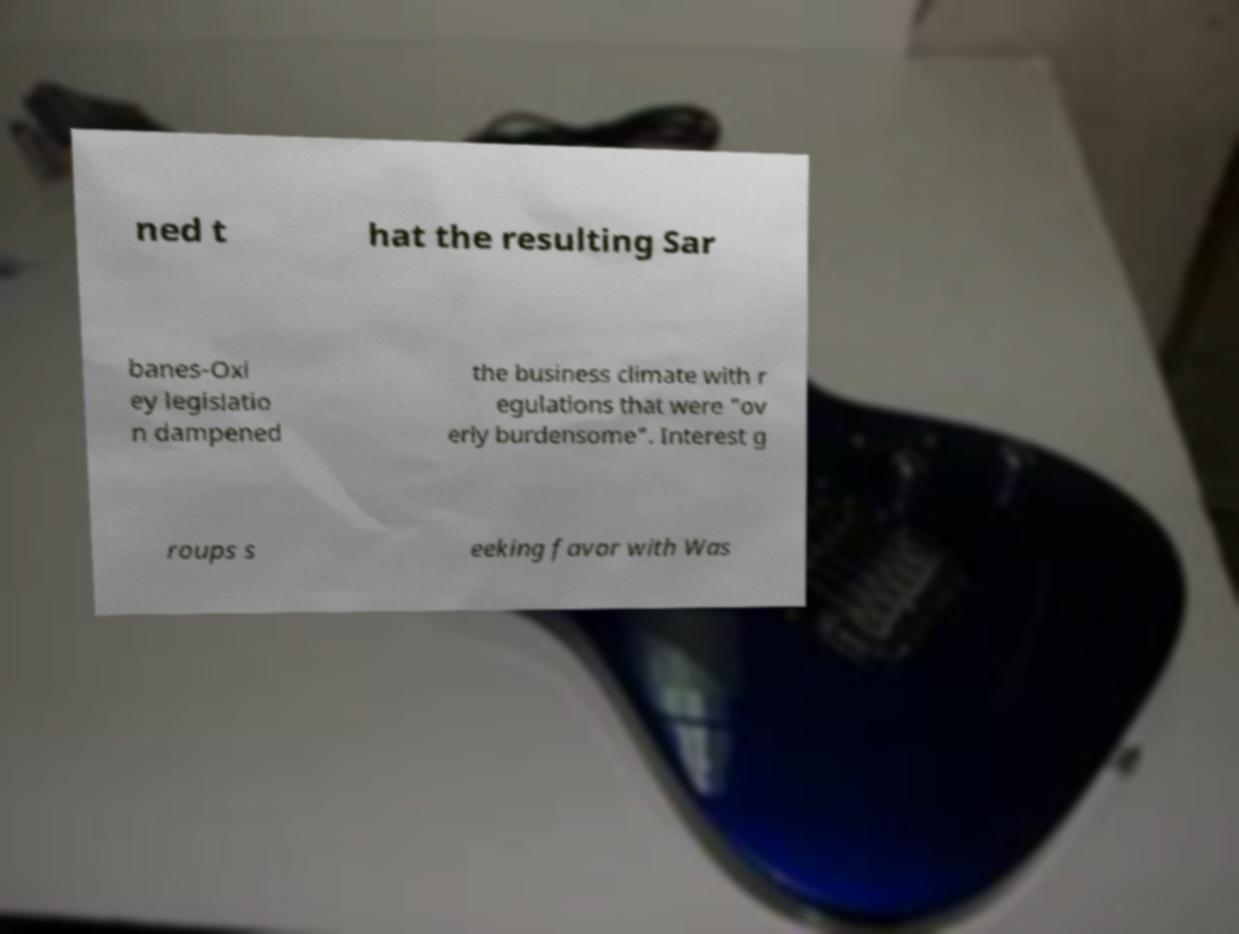There's text embedded in this image that I need extracted. Can you transcribe it verbatim? ned t hat the resulting Sar banes-Oxl ey legislatio n dampened the business climate with r egulations that were "ov erly burdensome". Interest g roups s eeking favor with Was 